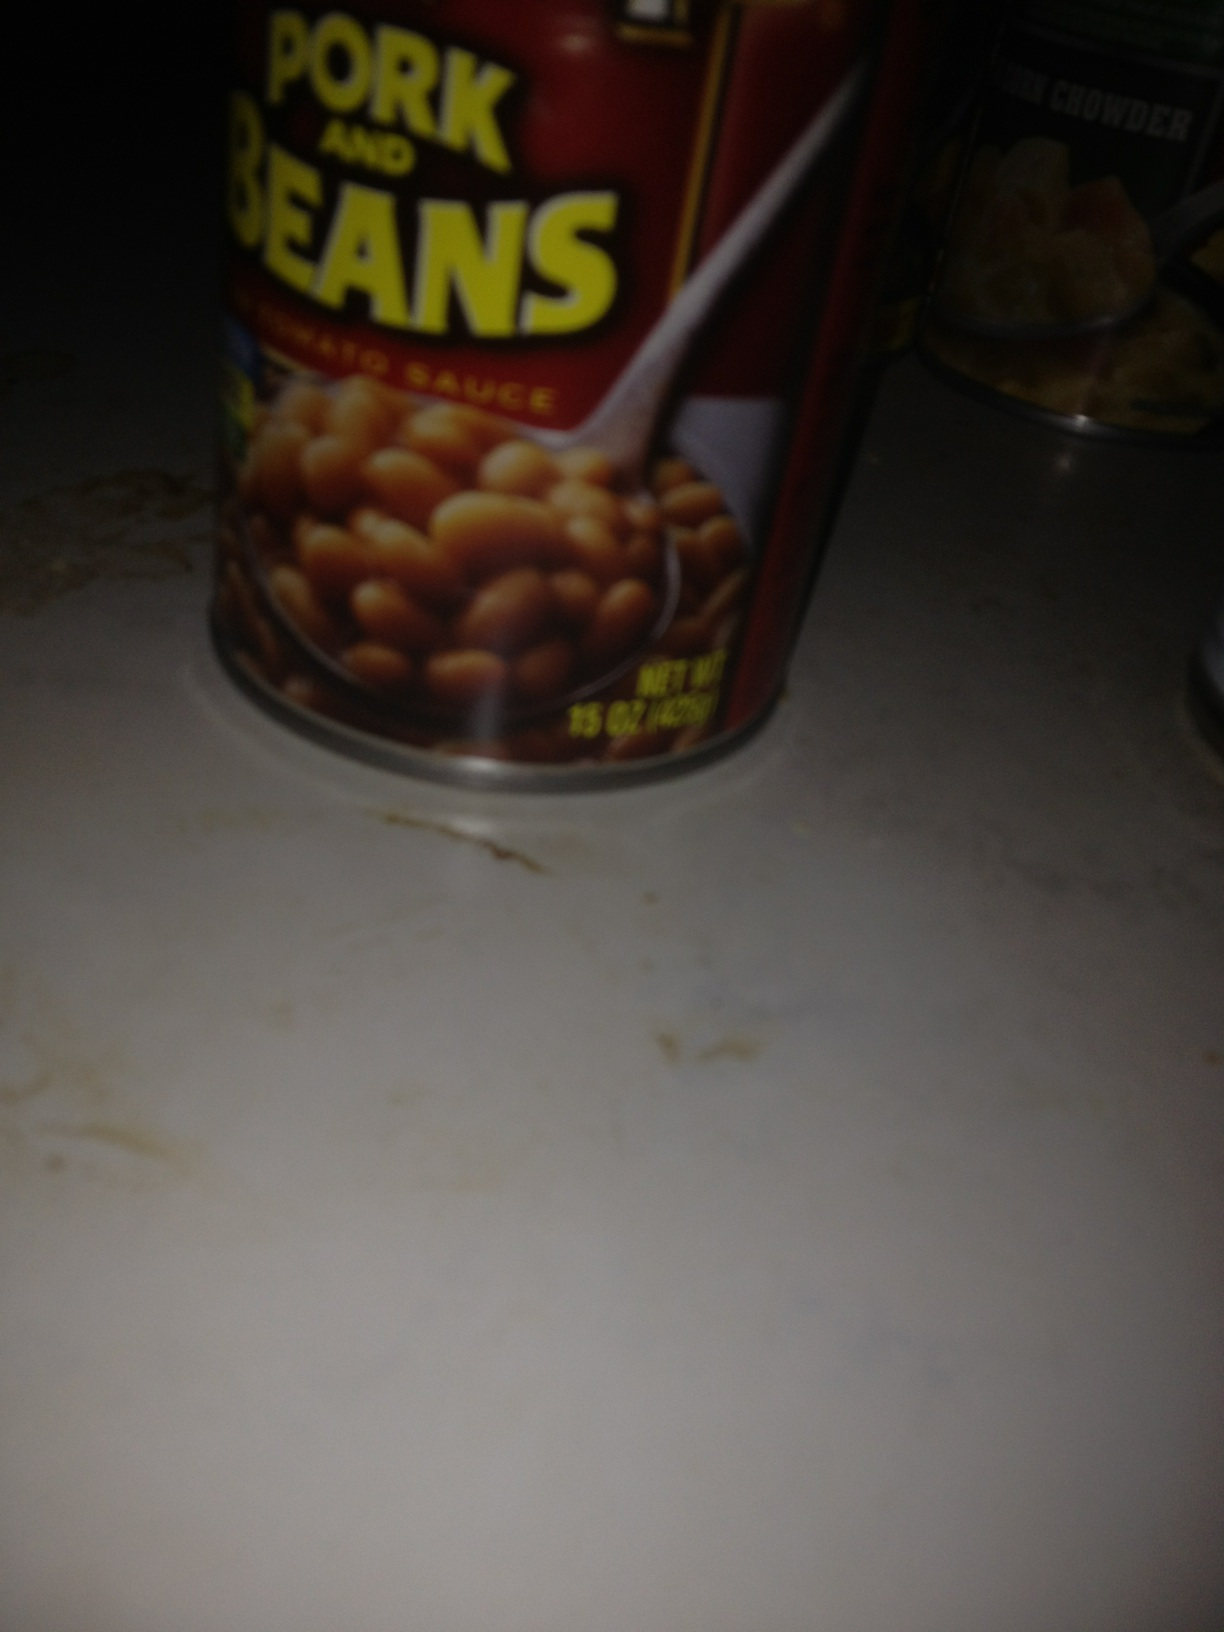If these cans were to come to life, what kind of adventure would they go on? Imagine the can of Pork and Beans and the can of New England Clam Chowder springing to life one night. They set off on an adventure across the kitchen, navigating the treacherous terrain of countertops and dodging the towering forks and knives. Their mission: to explore the uncharted territory known as 'The Pantry'. Along the way, they encounter fellow canned goods who share tales of mysterious spices and ancient recipes hidden deep within the pantry's dark corners. With teamwork and courage, they venture deeper and deeper, eventually uncovering a long-lost recipe book that holds the key to the perfect meal. Their adventure not only brings them closer together but also helps them understand that each ingredient has its own unique flavor to contribute to a dish, mirroring the diversity of friendship. 